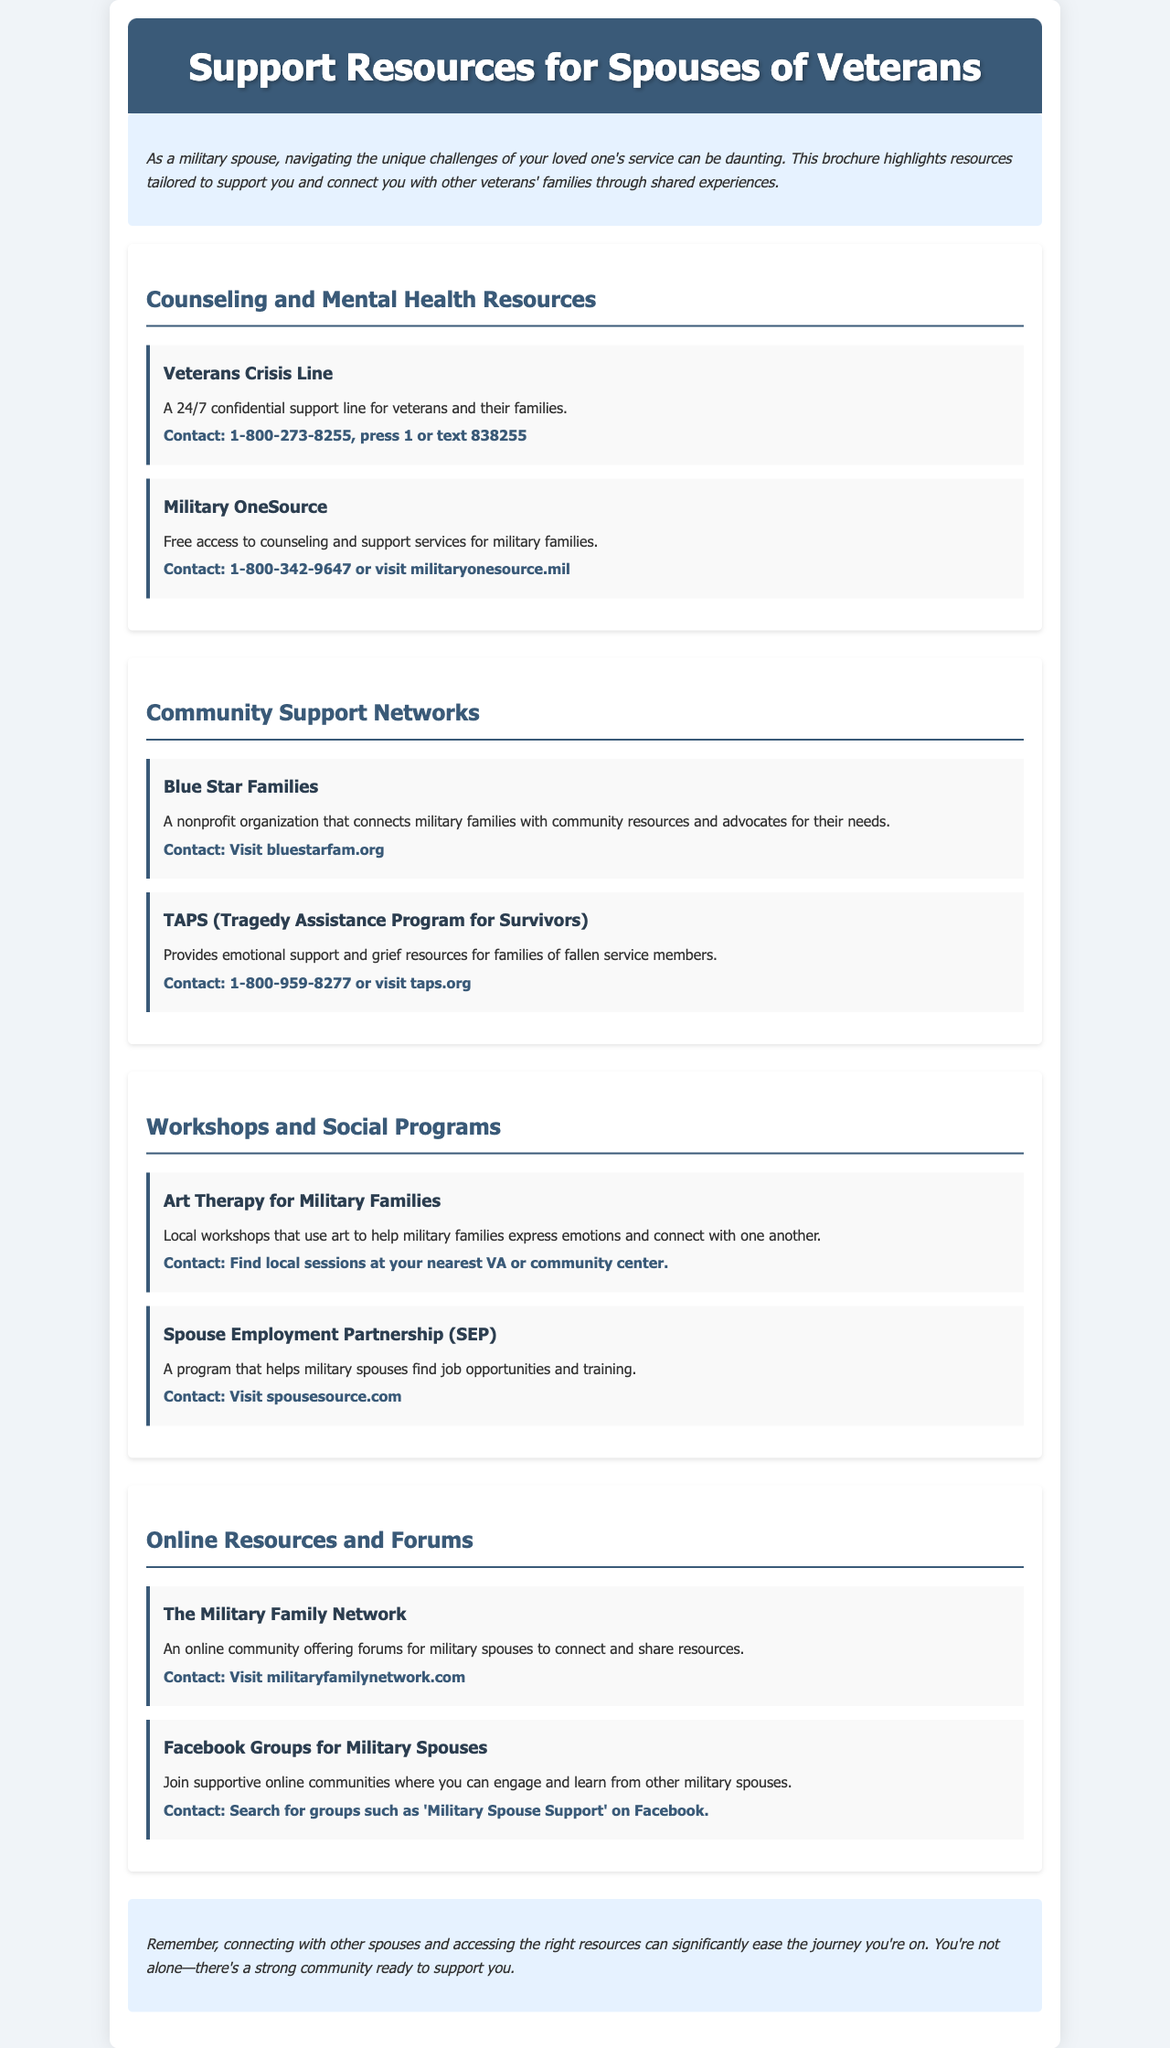What is the title of the brochure? The title of the brochure is prominently displayed at the top of the document.
Answer: Support Resources for Spouses of Veterans What is the contact number for the Veterans Crisis Line? The contact number for the Veterans Crisis Line is listed in the section about counseling and mental health resources.
Answer: 1-800-273-8255, press 1 or text 838255 Who can benefit from the Art Therapy for Military Families workshops? The workshops are specifically designed for a certain group of people, as indicated in the document.
Answer: Military families What organization connects military families with community resources? The resource that focuses on connecting military families with community resources is detailed in the document.
Answer: Blue Star Families What type of support does TAPS provide? The document specifies the kind of emotional assistance TAPS offers to a certain demographic.
Answer: Grief resources How can military spouses find job opportunities and training? The document refers to a specific program that assists military spouses with finding job opportunities.
Answer: Spouse Employment Partnership (SEP) Where can supportive online communities for military spouses be found? The document mentions a specific type of resource where military spouses can find community support.
Answer: Facebook Groups In what year does the brochure suggest connecting with other spouses can ease the journey? This is a matter regarding the significance of support as per the conclusion section of the brochure.
Answer: 2023 (implied by current context) What kind of programs does Military OneSource offer? The document details the services provided by Military OneSource under a specific section.
Answer: Counseling and support services 